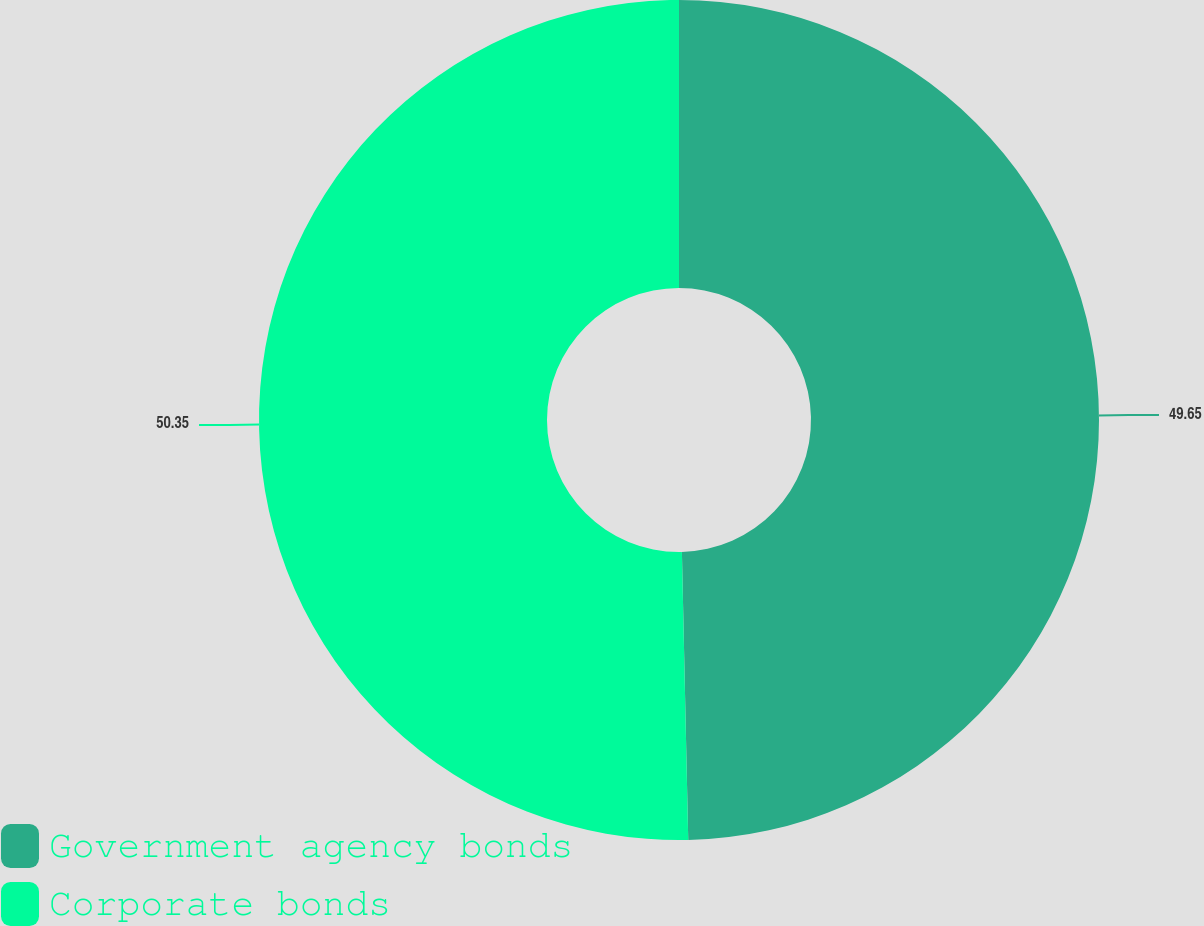<chart> <loc_0><loc_0><loc_500><loc_500><pie_chart><fcel>Government agency bonds<fcel>Corporate bonds<nl><fcel>49.65%<fcel>50.35%<nl></chart> 